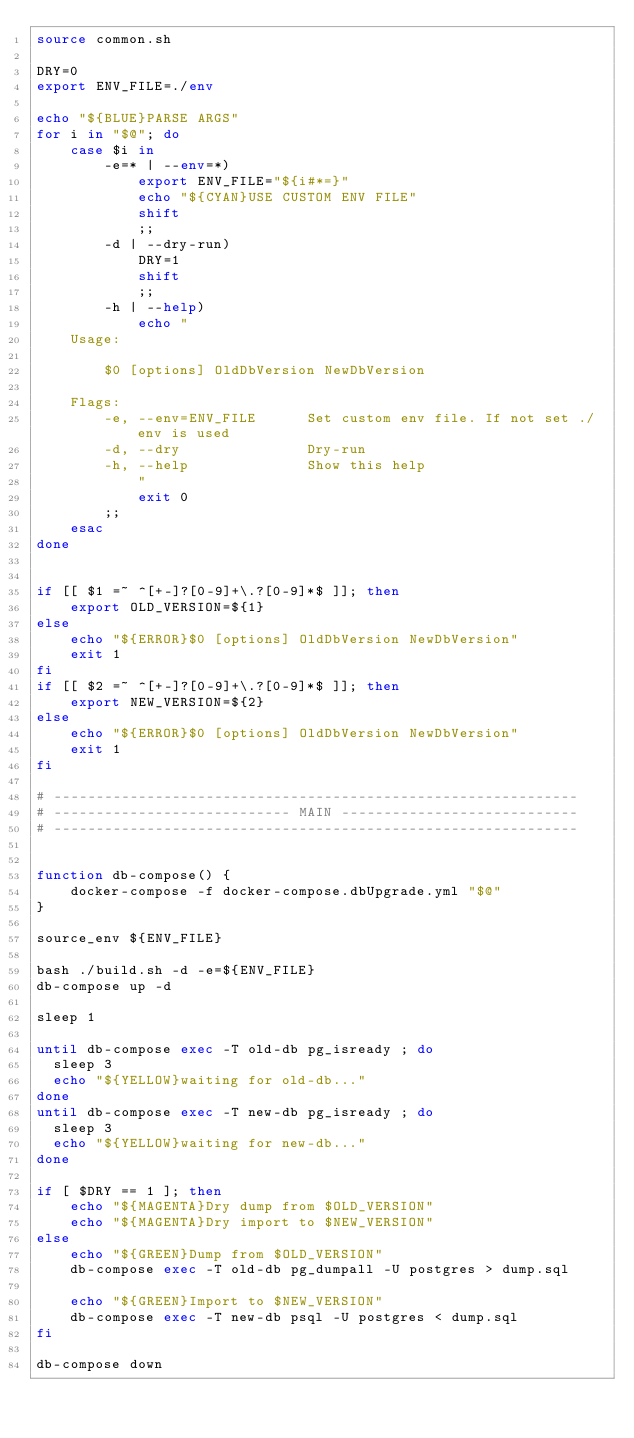<code> <loc_0><loc_0><loc_500><loc_500><_Bash_>source common.sh

DRY=0
export ENV_FILE=./env

echo "${BLUE}PARSE ARGS"
for i in "$@"; do
    case $i in
        -e=* | --env=*)
            export ENV_FILE="${i#*=}"
            echo "${CYAN}USE CUSTOM ENV FILE"
            shift
            ;;
        -d | --dry-run)
            DRY=1
            shift
            ;;
        -h | --help)
            echo "
    Usage:

        $0 [options] OldDbVersion NewDbVersion

    Flags:
        -e, --env=ENV_FILE      Set custom env file. If not set ./env is used
        -d, --dry               Dry-run
        -h, --help              Show this help
            "
            exit 0
        ;;
    esac
done


if [[ $1 =~ ^[+-]?[0-9]+\.?[0-9]*$ ]]; then
    export OLD_VERSION=${1}
else
    echo "${ERROR}$0 [options] OldDbVersion NewDbVersion"
    exit 1
fi
if [[ $2 =~ ^[+-]?[0-9]+\.?[0-9]*$ ]]; then
    export NEW_VERSION=${2}
else
    echo "${ERROR}$0 [options] OldDbVersion NewDbVersion"
    exit 1
fi

# --------------------------------------------------------------
# ---------------------------- MAIN ----------------------------
# --------------------------------------------------------------


function db-compose() {
    docker-compose -f docker-compose.dbUpgrade.yml "$@"
}

source_env ${ENV_FILE}

bash ./build.sh -d -e=${ENV_FILE} 
db-compose up -d

sleep 1

until db-compose exec -T old-db pg_isready ; do
	sleep 3
	echo "${YELLOW}waiting for old-db..."	
done
until db-compose exec -T new-db pg_isready ; do
	sleep 3
	echo "${YELLOW}waiting for new-db..."	
done

if [ $DRY == 1 ]; then
    echo "${MAGENTA}Dry dump from $OLD_VERSION"
    echo "${MAGENTA}Dry import to $NEW_VERSION"
else
    echo "${GREEN}Dump from $OLD_VERSION"
    db-compose exec -T old-db pg_dumpall -U postgres > dump.sql

    echo "${GREEN}Import to $NEW_VERSION"
    db-compose exec -T new-db psql -U postgres < dump.sql
fi

db-compose down
</code> 